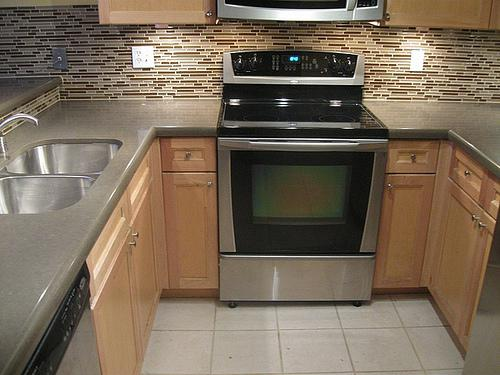Question: who is in the kitchen?
Choices:
A. No one.
B. Family.
C. Kids.
D. Man.
Answer with the letter. Answer: A Question: what is the drawers made of?
Choices:
A. Plastic.
B. Wood.
C. Cardboard.
D. Vinyl.
Answer with the letter. Answer: B 